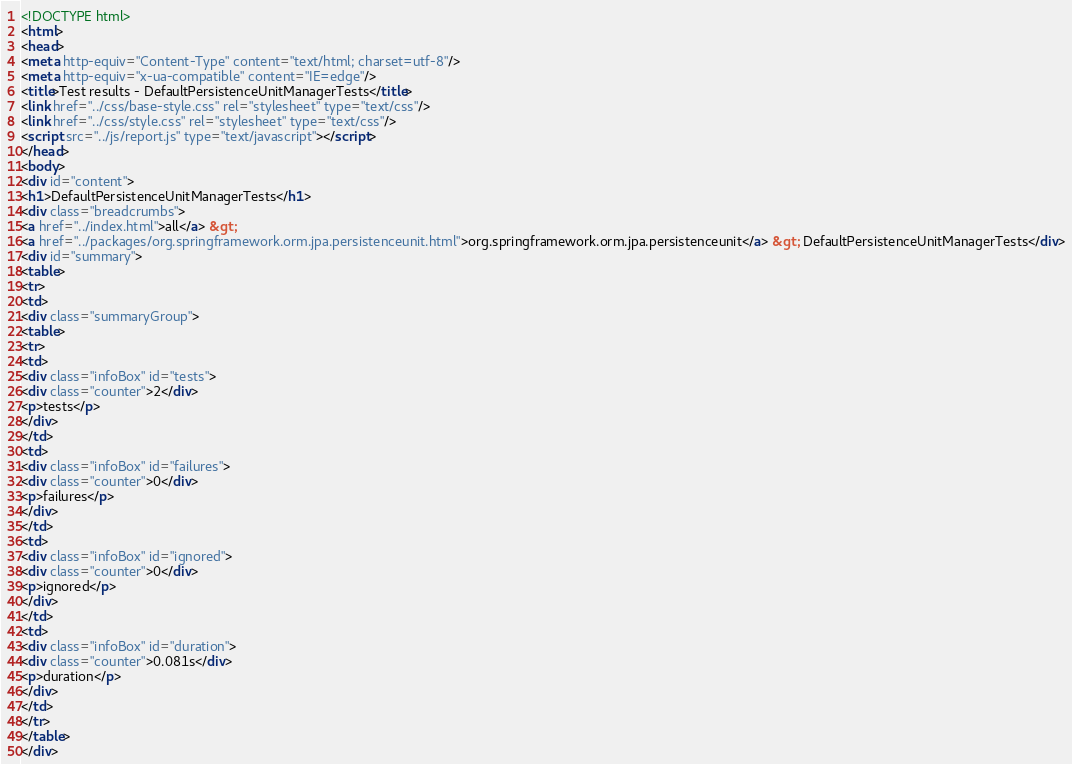<code> <loc_0><loc_0><loc_500><loc_500><_HTML_><!DOCTYPE html>
<html>
<head>
<meta http-equiv="Content-Type" content="text/html; charset=utf-8"/>
<meta http-equiv="x-ua-compatible" content="IE=edge"/>
<title>Test results - DefaultPersistenceUnitManagerTests</title>
<link href="../css/base-style.css" rel="stylesheet" type="text/css"/>
<link href="../css/style.css" rel="stylesheet" type="text/css"/>
<script src="../js/report.js" type="text/javascript"></script>
</head>
<body>
<div id="content">
<h1>DefaultPersistenceUnitManagerTests</h1>
<div class="breadcrumbs">
<a href="../index.html">all</a> &gt; 
<a href="../packages/org.springframework.orm.jpa.persistenceunit.html">org.springframework.orm.jpa.persistenceunit</a> &gt; DefaultPersistenceUnitManagerTests</div>
<div id="summary">
<table>
<tr>
<td>
<div class="summaryGroup">
<table>
<tr>
<td>
<div class="infoBox" id="tests">
<div class="counter">2</div>
<p>tests</p>
</div>
</td>
<td>
<div class="infoBox" id="failures">
<div class="counter">0</div>
<p>failures</p>
</div>
</td>
<td>
<div class="infoBox" id="ignored">
<div class="counter">0</div>
<p>ignored</p>
</div>
</td>
<td>
<div class="infoBox" id="duration">
<div class="counter">0.081s</div>
<p>duration</p>
</div>
</td>
</tr>
</table>
</div></code> 